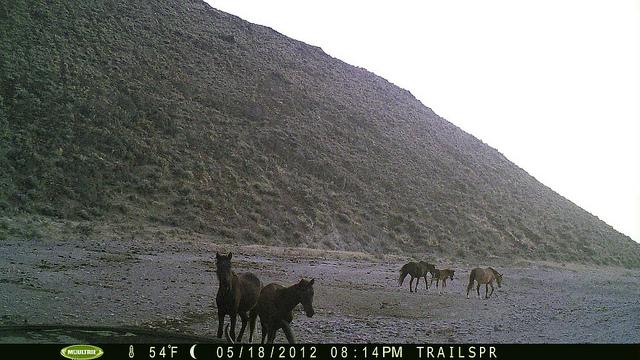Is there a large hill?
Be succinct. Yes. Why might the horse be in danger of falling?
Write a very short answer. Rocks. How many horses are facing towards the camera?
Short answer required. 2. Are the horses being ridden?
Write a very short answer. No. 